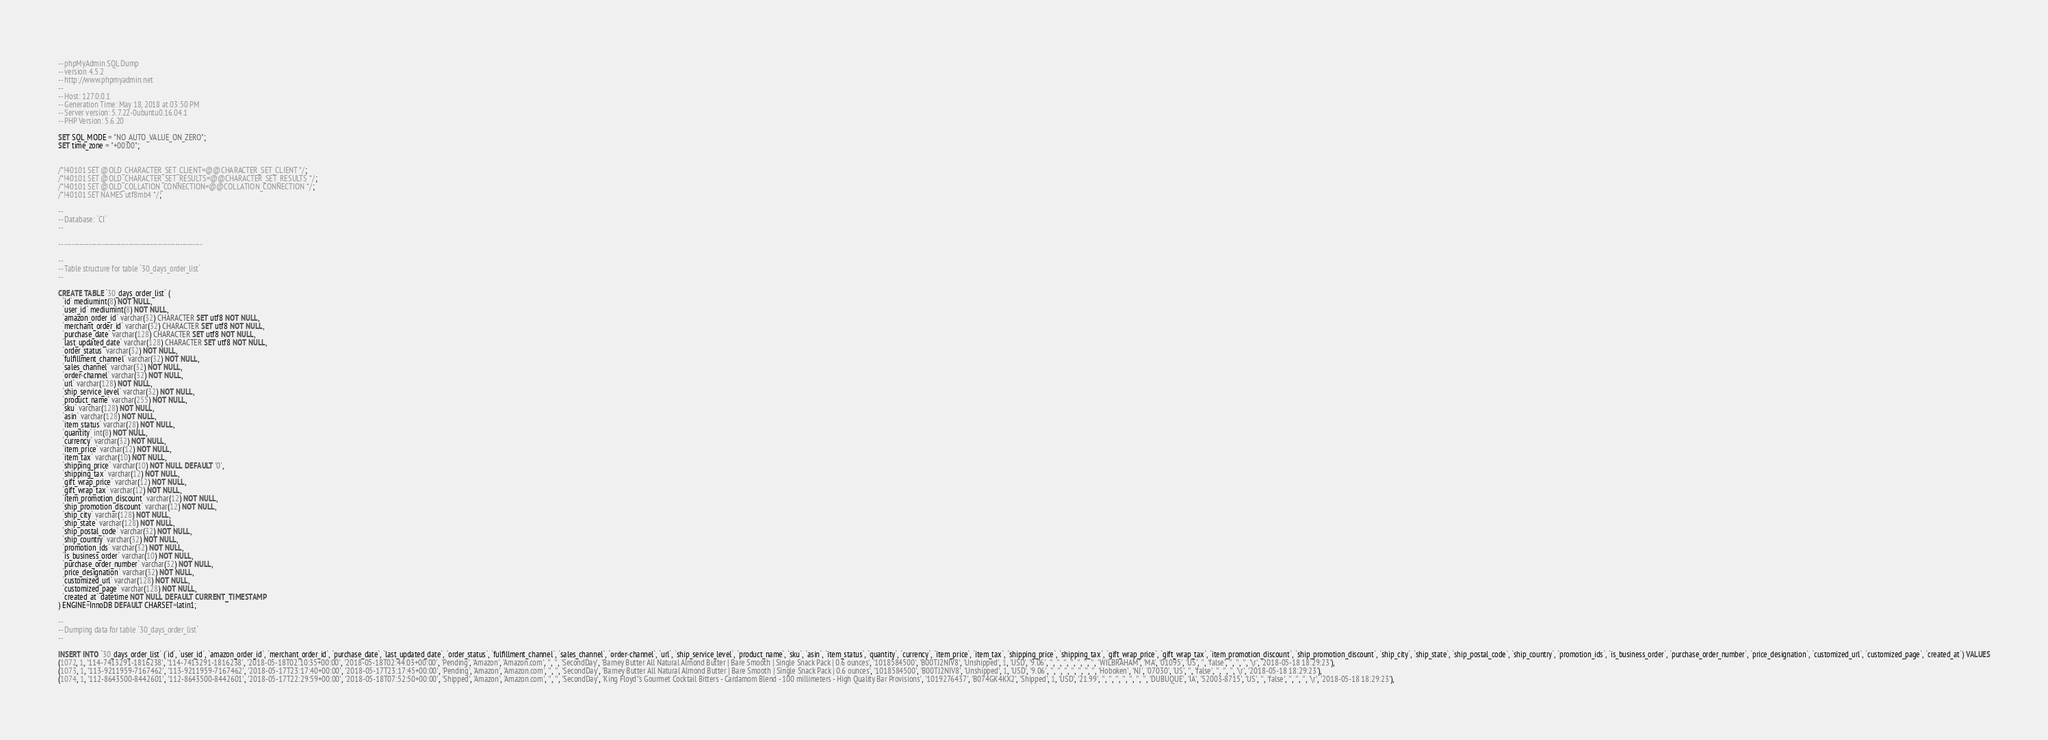Convert code to text. <code><loc_0><loc_0><loc_500><loc_500><_SQL_>-- phpMyAdmin SQL Dump
-- version 4.5.2
-- http://www.phpmyadmin.net
--
-- Host: 127.0.0.1
-- Generation Time: May 18, 2018 at 03:50 PM
-- Server version: 5.7.22-0ubuntu0.16.04.1
-- PHP Version: 5.6.20

SET SQL_MODE = "NO_AUTO_VALUE_ON_ZERO";
SET time_zone = "+00:00";


/*!40101 SET @OLD_CHARACTER_SET_CLIENT=@@CHARACTER_SET_CLIENT */;
/*!40101 SET @OLD_CHARACTER_SET_RESULTS=@@CHARACTER_SET_RESULTS */;
/*!40101 SET @OLD_COLLATION_CONNECTION=@@COLLATION_CONNECTION */;
/*!40101 SET NAMES utf8mb4 */;

--
-- Database: `CI`
--

-- --------------------------------------------------------

--
-- Table structure for table `30_days_order_list`
--

CREATE TABLE `30_days_order_list` (
  `id` mediumint(8) NOT NULL,
  `user_id` mediumint(8) NOT NULL,
  `amazon_order_id` varchar(32) CHARACTER SET utf8 NOT NULL,
  `merchant_order_id` varchar(32) CHARACTER SET utf8 NOT NULL,
  `purchase_date` varchar(128) CHARACTER SET utf8 NOT NULL,
  `last_updated_date` varchar(128) CHARACTER SET utf8 NOT NULL,
  `order_status` varchar(32) NOT NULL,
  `fulfillment_channel` varchar(32) NOT NULL,
  `sales_channel` varchar(32) NOT NULL,
  `order-channel` varchar(32) NOT NULL,
  `url` varchar(128) NOT NULL,
  `ship_service_level` varchar(32) NOT NULL,
  `product_name` varchar(255) NOT NULL,
  `sku` varchar(128) NOT NULL,
  `asin` varchar(128) NOT NULL,
  `item_status` varchar(28) NOT NULL,
  `quantity` int(8) NOT NULL,
  `currency` varchar(32) NOT NULL,
  `item_price` varchar(12) NOT NULL,
  `item_tax` varchar(10) NOT NULL,
  `shipping_price` varchar(10) NOT NULL DEFAULT '0',
  `shipping_tax` varchar(12) NOT NULL,
  `gift_wrap_price` varchar(12) NOT NULL,
  `gift_wrap_tax` varchar(12) NOT NULL,
  `item_promotion_discount` varchar(12) NOT NULL,
  `ship_promotion_discount` varchar(12) NOT NULL,
  `ship_city` varchar(128) NOT NULL,
  `ship_state` varchar(128) NOT NULL,
  `ship_postal_code` varchar(32) NOT NULL,
  `ship_country` varchar(32) NOT NULL,
  `promotion_ids` varchar(32) NOT NULL,
  `is_business_order` varchar(10) NOT NULL,
  `purchase_order_number` varchar(32) NOT NULL,
  `price_designation` varchar(32) NOT NULL,
  `customized_url` varchar(128) NOT NULL,
  `customized_page` varchar(128) NOT NULL,
  `created_at` datetime NOT NULL DEFAULT CURRENT_TIMESTAMP
) ENGINE=InnoDB DEFAULT CHARSET=latin1;

--
-- Dumping data for table `30_days_order_list`
--

INSERT INTO `30_days_order_list` (`id`, `user_id`, `amazon_order_id`, `merchant_order_id`, `purchase_date`, `last_updated_date`, `order_status`, `fulfillment_channel`, `sales_channel`, `order-channel`, `url`, `ship_service_level`, `product_name`, `sku`, `asin`, `item_status`, `quantity`, `currency`, `item_price`, `item_tax`, `shipping_price`, `shipping_tax`, `gift_wrap_price`, `gift_wrap_tax`, `item_promotion_discount`, `ship_promotion_discount`, `ship_city`, `ship_state`, `ship_postal_code`, `ship_country`, `promotion_ids`, `is_business_order`, `purchase_order_number`, `price_designation`, `customized_url`, `customized_page`, `created_at`) VALUES
(1072, 1, '114-7413291-1816238', '114-7413291-1816238', '2018-05-18T02:10:35+00:00', '2018-05-18T02:44:03+00:00', 'Pending', 'Amazon', 'Amazon.com', '', '', 'SecondDay', 'Barney Butter All Natural Almond Butter | Bare Smooth | Single Snack Pack | 0.6 ounces', '1018584500', 'B00TJ2NIV8', 'Unshipped', 1, 'USD', '9.06', '', '', '', '', '', '', '', 'WILBRAHAM', 'MA', '01095', 'US', '', 'false', '', '', '', '\r', '2018-05-18 18:29:23'),
(1073, 1, '113-9211959-7167462', '113-9211959-7167462', '2018-05-17T23:17:40+00:00', '2018-05-17T23:17:45+00:00', 'Pending', 'Amazon', 'Amazon.com', '', '', 'SecondDay', 'Barney Butter All Natural Almond Butter | Bare Smooth | Single Snack Pack | 0.6 ounces', '1018584500', 'B00TJ2NIV8', 'Unshipped', 1, 'USD', '9.06', '', '', '', '', '', '', '', 'Hoboken', 'NJ', '07030', 'US', '', 'false', '', '', '', '\r', '2018-05-18 18:29:23'),
(1074, 1, '112-8643500-8442601', '112-8643500-8442601', '2018-05-17T22:29:59+00:00', '2018-05-18T07:52:50+00:00', 'Shipped', 'Amazon', 'Amazon.com', '', '', 'SecondDay', 'King Floyd''s Gourmet Cocktail Bitters - Cardamom Blend - 100 millimeters - High Quality Bar Provisions', '1019276437', 'B074GK4KX2', 'Shipped', 1, 'USD', '21.99', '', '', '', '', '', '', '', 'DUBUQUE', 'IA', '52003-8715', 'US', '', 'false', '', '', '', '\r', '2018-05-18 18:29:23'),</code> 